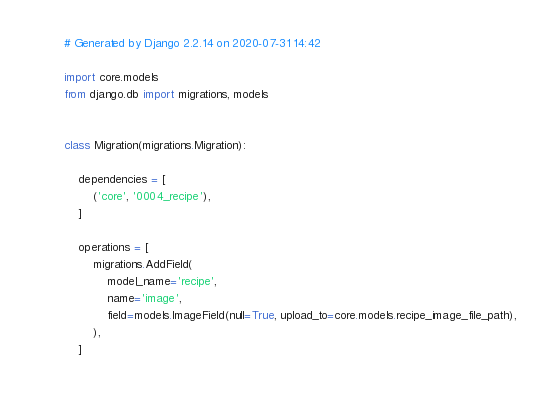<code> <loc_0><loc_0><loc_500><loc_500><_Python_># Generated by Django 2.2.14 on 2020-07-31 14:42

import core.models
from django.db import migrations, models


class Migration(migrations.Migration):

    dependencies = [
        ('core', '0004_recipe'),
    ]

    operations = [
        migrations.AddField(
            model_name='recipe',
            name='image',
            field=models.ImageField(null=True, upload_to=core.models.recipe_image_file_path),
        ),
    ]
</code> 